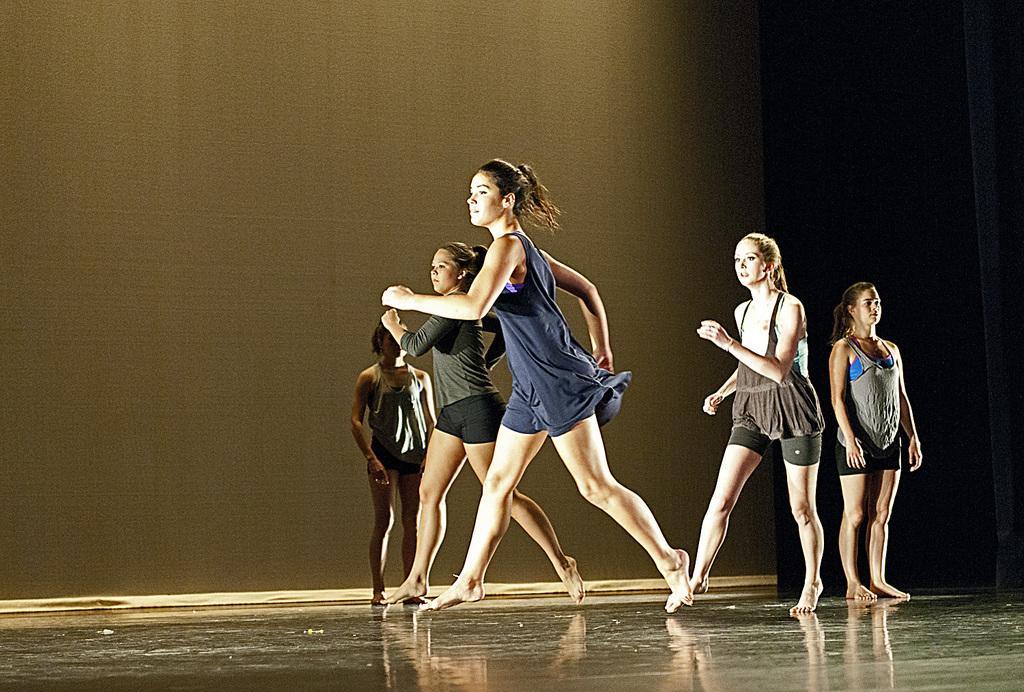How would you summarize this image in a sentence or two? In this image, we can see people dancing and some are standing on the floor and in the background, there is a curtain. 